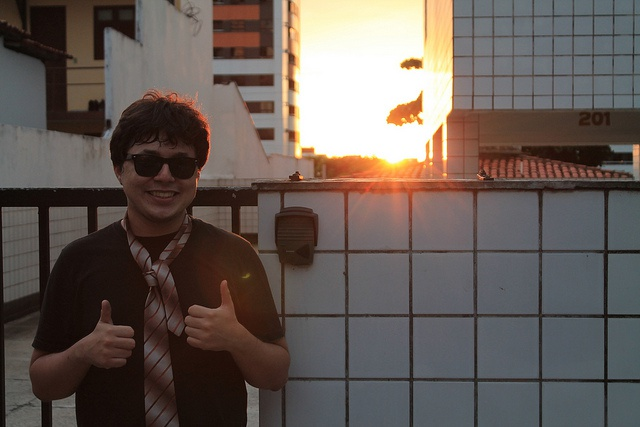Describe the objects in this image and their specific colors. I can see people in black, maroon, and gray tones and tie in black, maroon, and gray tones in this image. 